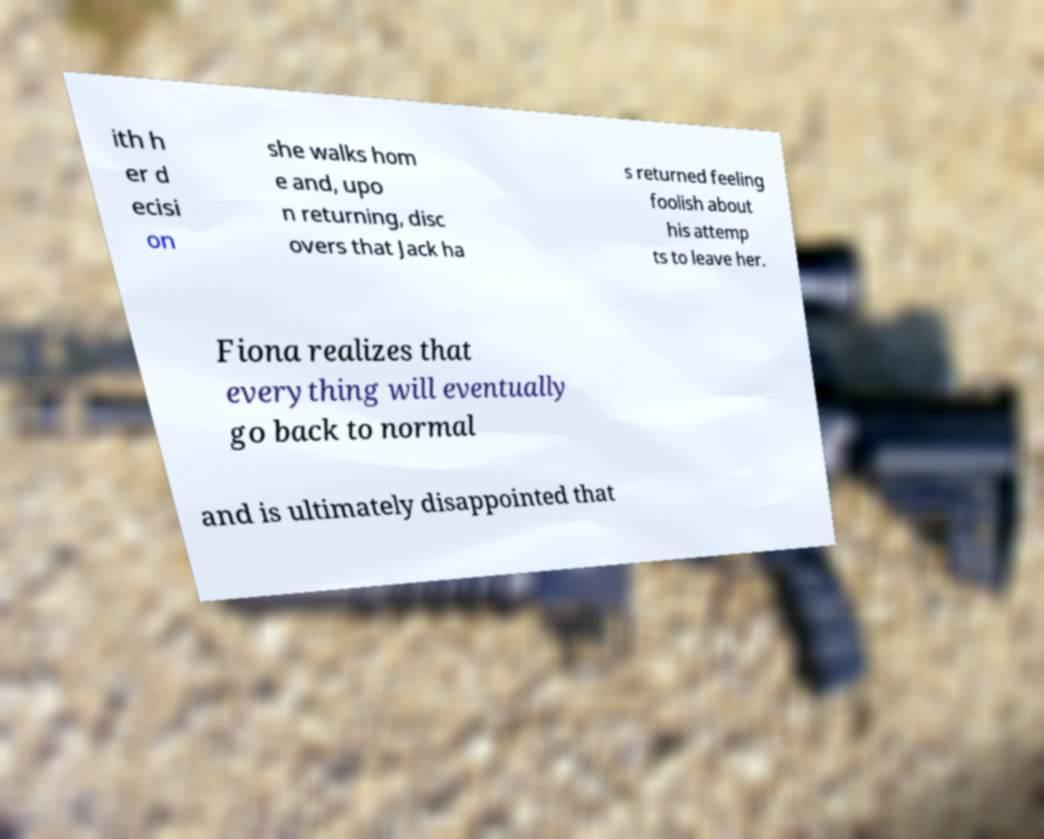For documentation purposes, I need the text within this image transcribed. Could you provide that? ith h er d ecisi on she walks hom e and, upo n returning, disc overs that Jack ha s returned feeling foolish about his attemp ts to leave her. Fiona realizes that everything will eventually go back to normal and is ultimately disappointed that 